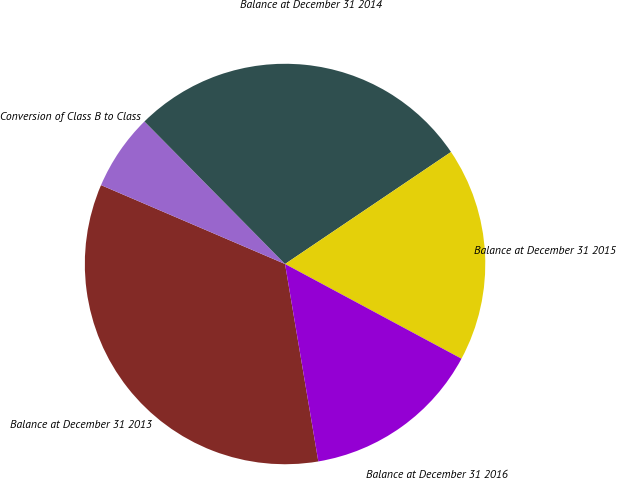Convert chart. <chart><loc_0><loc_0><loc_500><loc_500><pie_chart><fcel>Balance at December 31 2013<fcel>Conversion of Class B to Class<fcel>Balance at December 31 2014<fcel>Balance at December 31 2015<fcel>Balance at December 31 2016<nl><fcel>34.1%<fcel>6.16%<fcel>27.94%<fcel>17.29%<fcel>14.5%<nl></chart> 